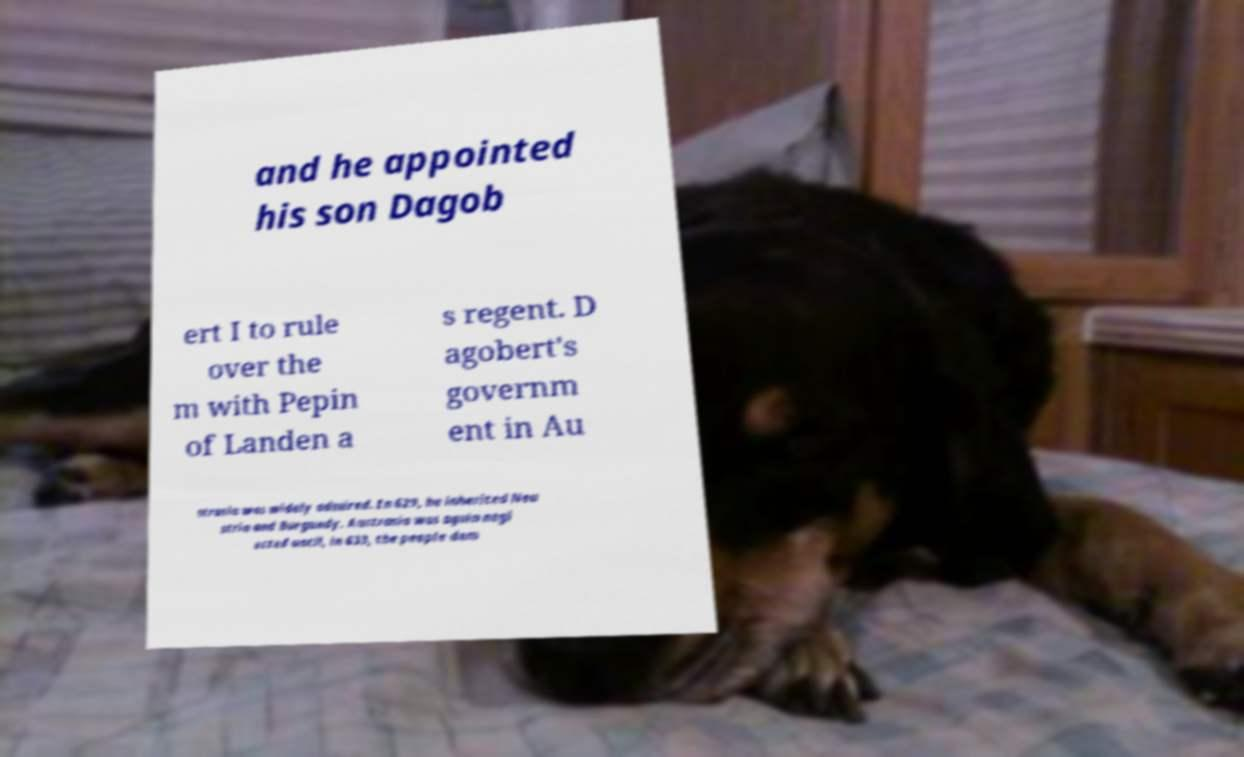Could you assist in decoding the text presented in this image and type it out clearly? and he appointed his son Dagob ert I to rule over the m with Pepin of Landen a s regent. D agobert's governm ent in Au strasia was widely admired. In 629, he inherited Neu stria and Burgundy. Austrasia was again negl ected until, in 633, the people dem 